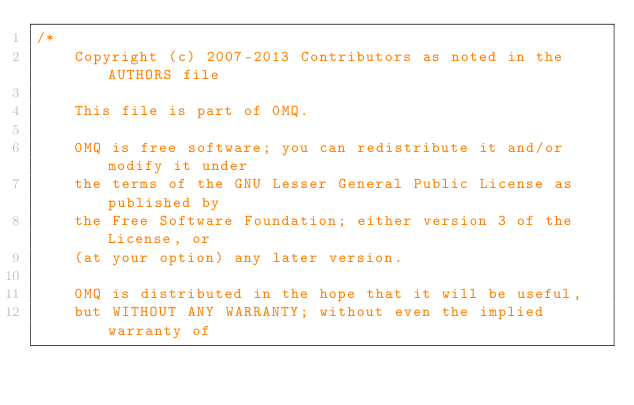<code> <loc_0><loc_0><loc_500><loc_500><_C++_>/*
    Copyright (c) 2007-2013 Contributors as noted in the AUTHORS file

    This file is part of 0MQ.

    0MQ is free software; you can redistribute it and/or modify it under
    the terms of the GNU Lesser General Public License as published by
    the Free Software Foundation; either version 3 of the License, or
    (at your option) any later version.

    0MQ is distributed in the hope that it will be useful,
    but WITHOUT ANY WARRANTY; without even the implied warranty of</code> 